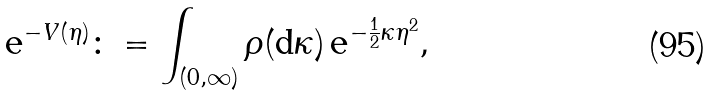Convert formula to latex. <formula><loc_0><loc_0><loc_500><loc_500>\text  e^{-V(\eta)} \colon = \int _ { ( 0 , \infty ) } \rho ( \text  d\kappa)\,\text  e^{-\frac{1}{2}\kappa\eta^{2}} ,</formula> 